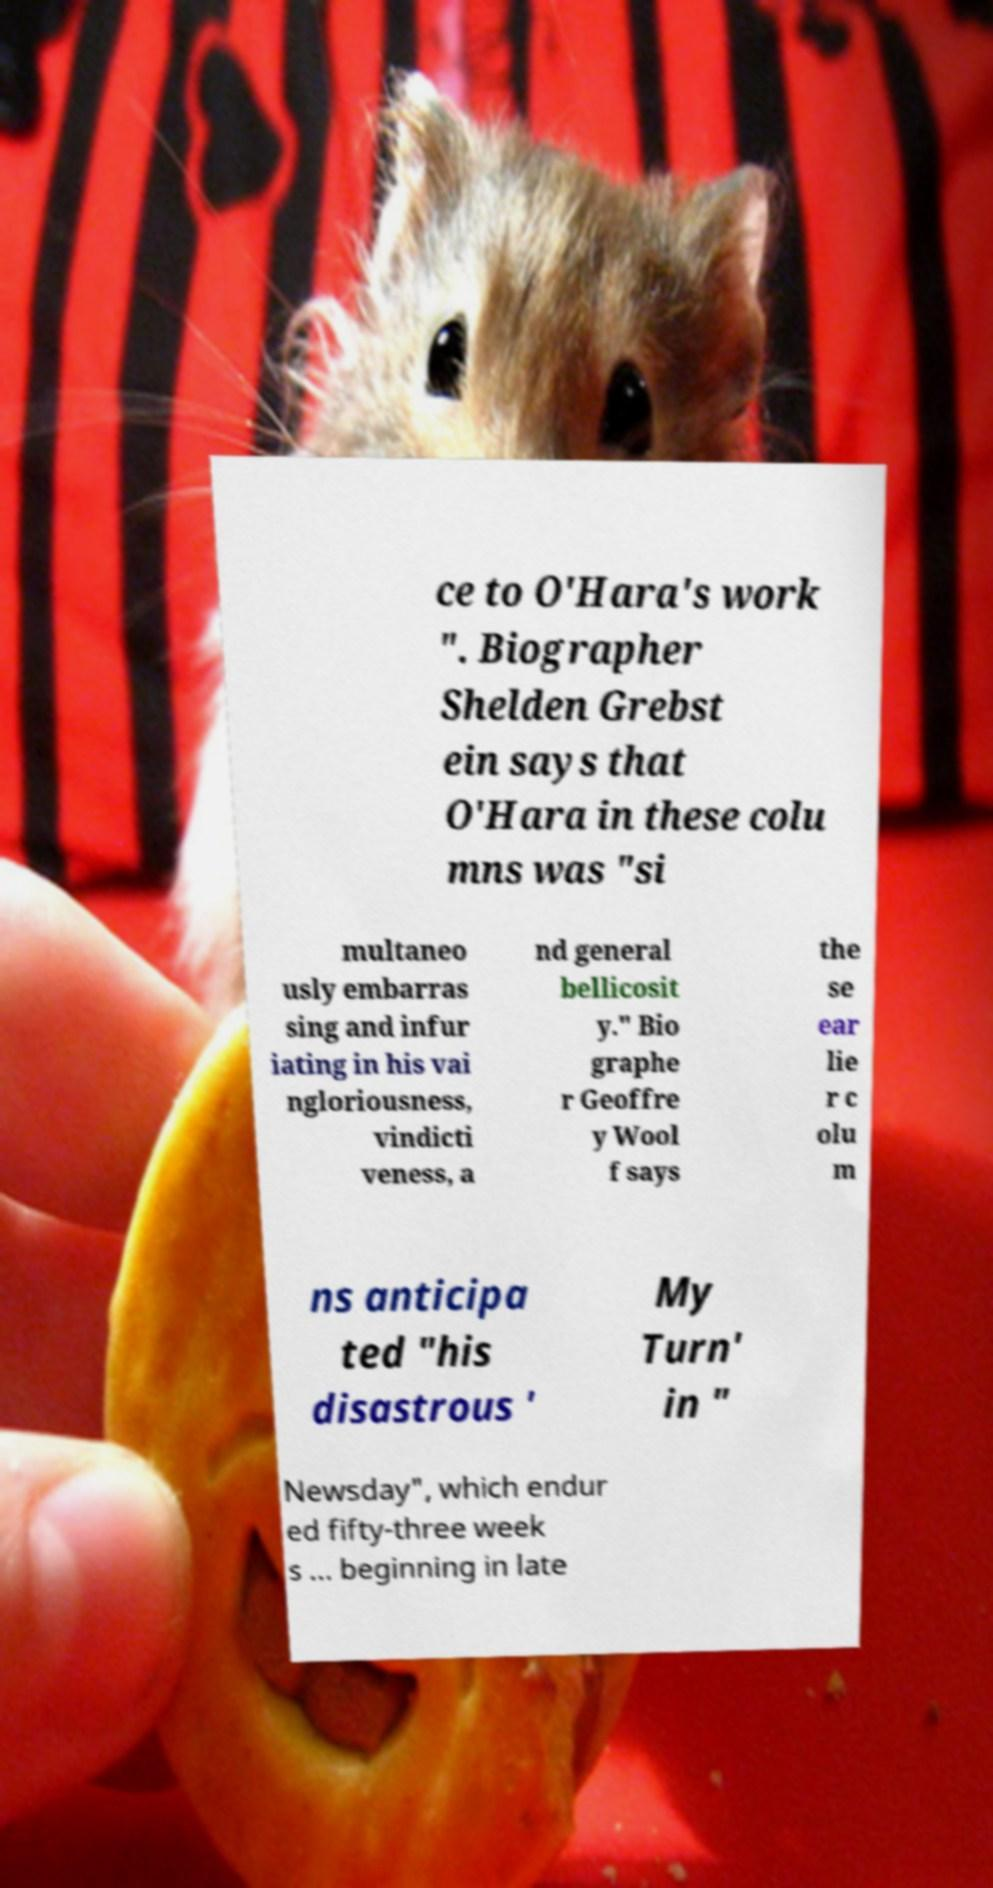For documentation purposes, I need the text within this image transcribed. Could you provide that? ce to O'Hara's work ". Biographer Shelden Grebst ein says that O'Hara in these colu mns was "si multaneo usly embarras sing and infur iating in his vai ngloriousness, vindicti veness, a nd general bellicosit y." Bio graphe r Geoffre y Wool f says the se ear lie r c olu m ns anticipa ted "his disastrous ' My Turn' in " Newsday", which endur ed fifty-three week s ... beginning in late 